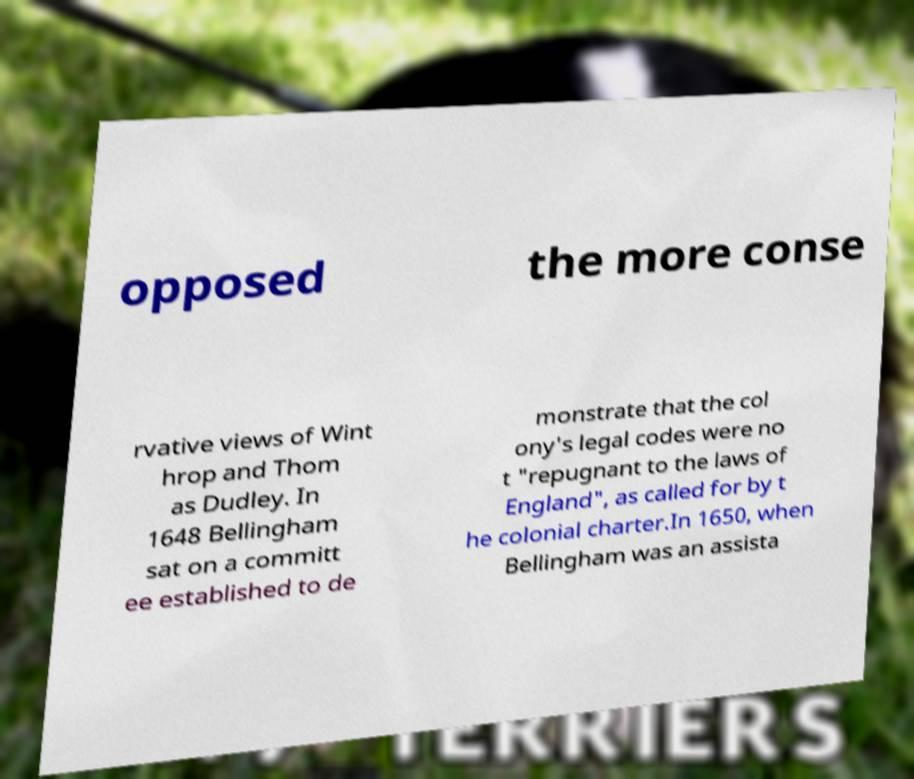There's text embedded in this image that I need extracted. Can you transcribe it verbatim? opposed the more conse rvative views of Wint hrop and Thom as Dudley. In 1648 Bellingham sat on a committ ee established to de monstrate that the col ony's legal codes were no t "repugnant to the laws of England", as called for by t he colonial charter.In 1650, when Bellingham was an assista 